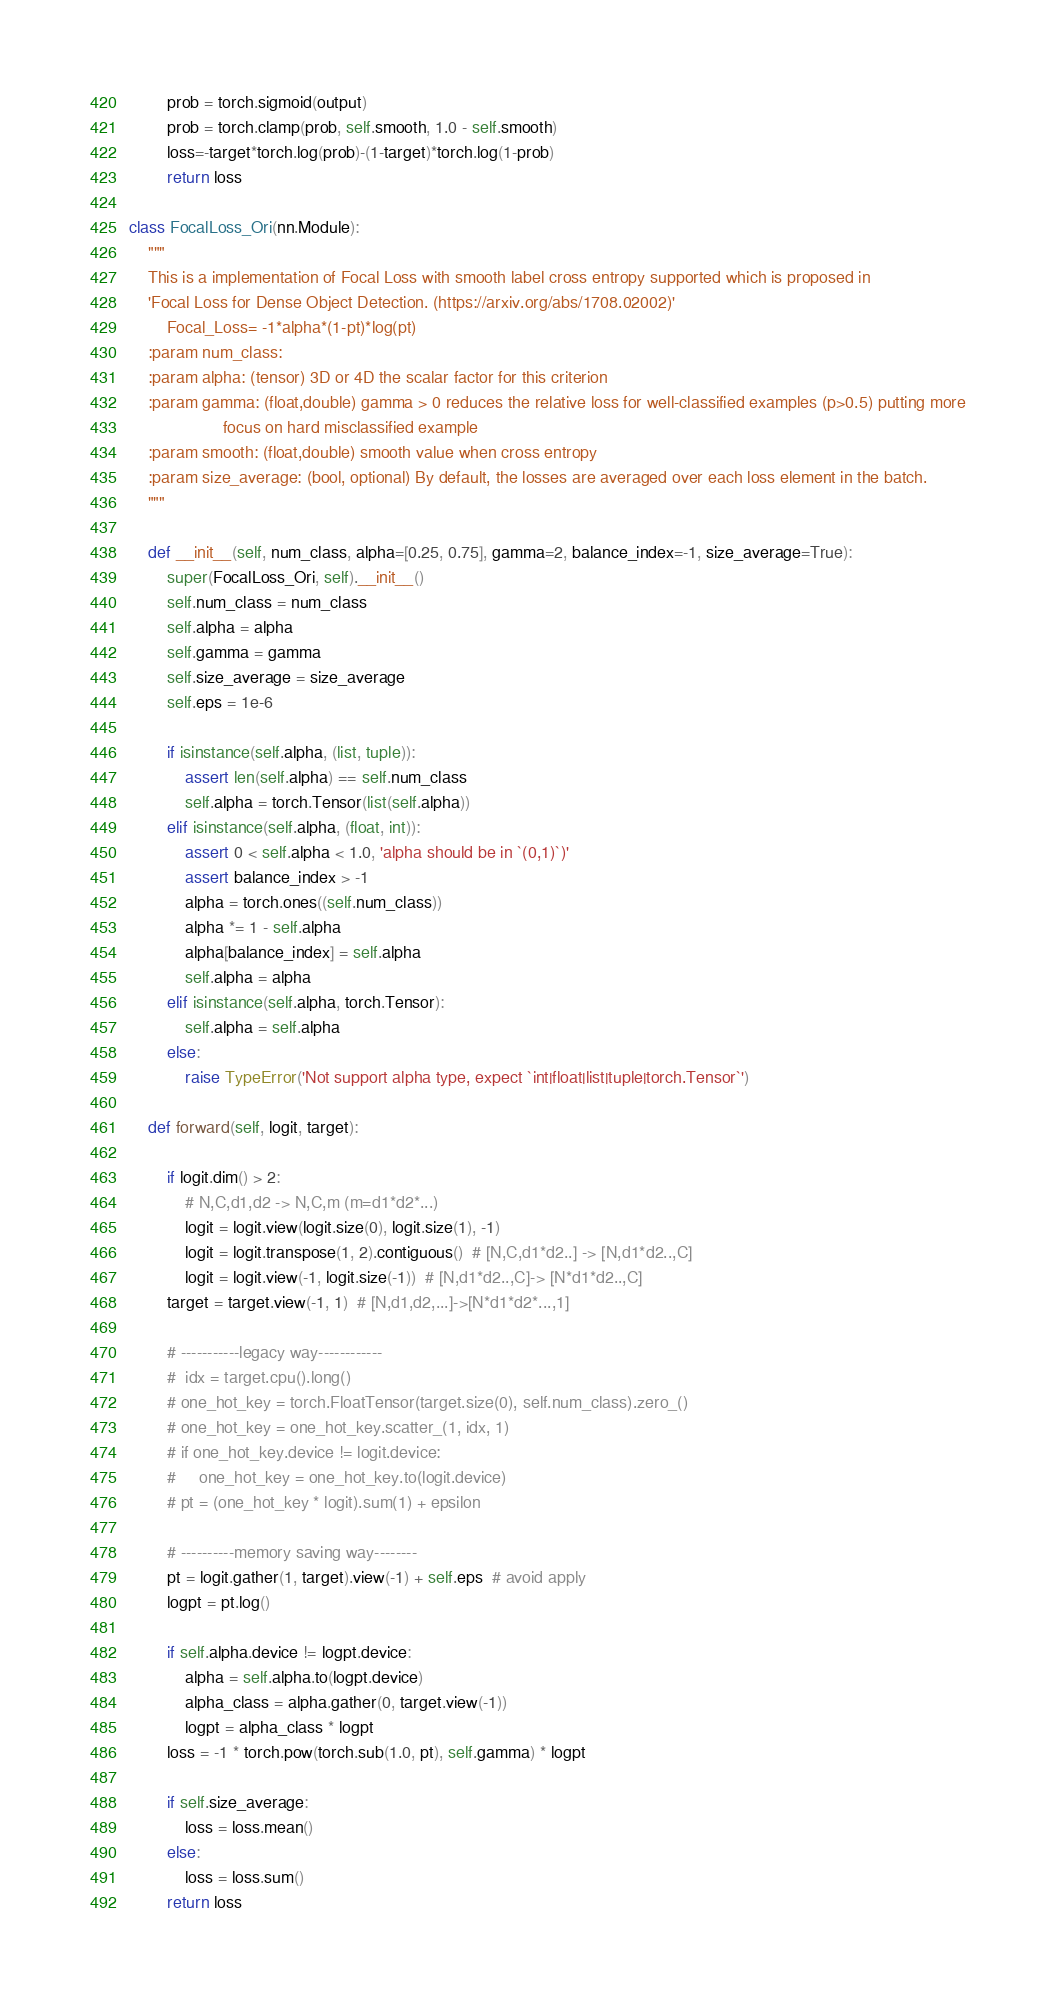Convert code to text. <code><loc_0><loc_0><loc_500><loc_500><_Python_>        prob = torch.sigmoid(output)
        prob = torch.clamp(prob, self.smooth, 1.0 - self.smooth)
        loss=-target*torch.log(prob)-(1-target)*torch.log(1-prob)
        return loss

class FocalLoss_Ori(nn.Module):
    """
    This is a implementation of Focal Loss with smooth label cross entropy supported which is proposed in
    'Focal Loss for Dense Object Detection. (https://arxiv.org/abs/1708.02002)'
        Focal_Loss= -1*alpha*(1-pt)*log(pt)
    :param num_class:
    :param alpha: (tensor) 3D or 4D the scalar factor for this criterion
    :param gamma: (float,double) gamma > 0 reduces the relative loss for well-classified examples (p>0.5) putting more
                    focus on hard misclassified example
    :param smooth: (float,double) smooth value when cross entropy
    :param size_average: (bool, optional) By default, the losses are averaged over each loss element in the batch.
    """

    def __init__(self, num_class, alpha=[0.25, 0.75], gamma=2, balance_index=-1, size_average=True):
        super(FocalLoss_Ori, self).__init__()
        self.num_class = num_class
        self.alpha = alpha
        self.gamma = gamma
        self.size_average = size_average
        self.eps = 1e-6

        if isinstance(self.alpha, (list, tuple)):
            assert len(self.alpha) == self.num_class
            self.alpha = torch.Tensor(list(self.alpha))
        elif isinstance(self.alpha, (float, int)):
            assert 0 < self.alpha < 1.0, 'alpha should be in `(0,1)`)'
            assert balance_index > -1
            alpha = torch.ones((self.num_class))
            alpha *= 1 - self.alpha
            alpha[balance_index] = self.alpha
            self.alpha = alpha
        elif isinstance(self.alpha, torch.Tensor):
            self.alpha = self.alpha
        else:
            raise TypeError('Not support alpha type, expect `int|float|list|tuple|torch.Tensor`')

    def forward(self, logit, target):

        if logit.dim() > 2:
            # N,C,d1,d2 -> N,C,m (m=d1*d2*...)
            logit = logit.view(logit.size(0), logit.size(1), -1)
            logit = logit.transpose(1, 2).contiguous()  # [N,C,d1*d2..] -> [N,d1*d2..,C]
            logit = logit.view(-1, logit.size(-1))  # [N,d1*d2..,C]-> [N*d1*d2..,C]
        target = target.view(-1, 1)  # [N,d1,d2,...]->[N*d1*d2*...,1]

        # -----------legacy way------------
        #  idx = target.cpu().long()
        # one_hot_key = torch.FloatTensor(target.size(0), self.num_class).zero_()
        # one_hot_key = one_hot_key.scatter_(1, idx, 1)
        # if one_hot_key.device != logit.device:
        #     one_hot_key = one_hot_key.to(logit.device)
        # pt = (one_hot_key * logit).sum(1) + epsilon

        # ----------memory saving way--------
        pt = logit.gather(1, target).view(-1) + self.eps  # avoid apply
        logpt = pt.log()

        if self.alpha.device != logpt.device:
            alpha = self.alpha.to(logpt.device)
            alpha_class = alpha.gather(0, target.view(-1))
            logpt = alpha_class * logpt
        loss = -1 * torch.pow(torch.sub(1.0, pt), self.gamma) * logpt

        if self.size_average:
            loss = loss.mean()
        else:
            loss = loss.sum()
        return loss

</code> 